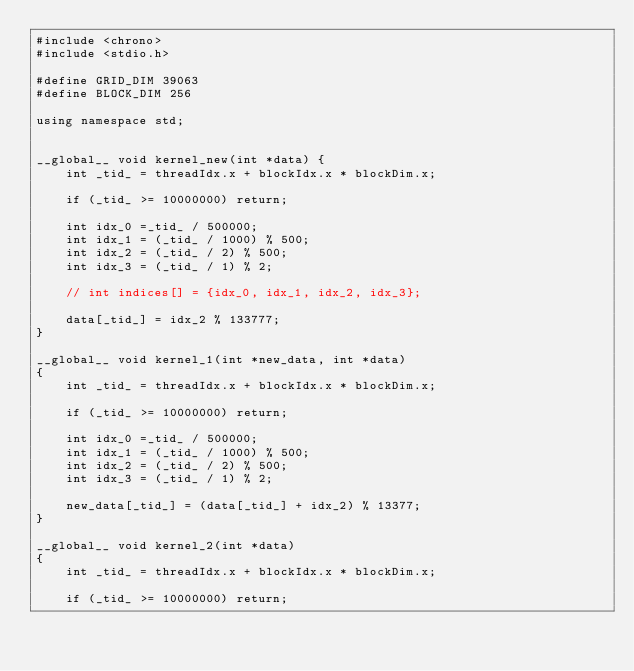<code> <loc_0><loc_0><loc_500><loc_500><_Cuda_>#include <chrono>
#include <stdio.h>

#define GRID_DIM 39063
#define BLOCK_DIM 256

using namespace std;


__global__ void kernel_new(int *data) {
    int _tid_ = threadIdx.x + blockIdx.x * blockDim.x;

    if (_tid_ >= 10000000) return;

    int idx_0 =_tid_ / 500000;
    int idx_1 = (_tid_ / 1000) % 500;
    int idx_2 = (_tid_ / 2) % 500;
    int idx_3 = (_tid_ / 1) % 2;

    // int indices[] = {idx_0, idx_1, idx_2, idx_3};

    data[_tid_] = idx_2 % 133777;
}

__global__ void kernel_1(int *new_data, int *data)
{
    int _tid_ = threadIdx.x + blockIdx.x * blockDim.x;

    if (_tid_ >= 10000000) return;

    int idx_0 =_tid_ / 500000;
    int idx_1 = (_tid_ / 1000) % 500;
    int idx_2 = (_tid_ / 2) % 500;
    int idx_3 = (_tid_ / 1) % 2;

    new_data[_tid_] = (data[_tid_] + idx_2) % 13377;
}

__global__ void kernel_2(int *data)
{
    int _tid_ = threadIdx.x + blockIdx.x * blockDim.x;

    if (_tid_ >= 10000000) return;
</code> 